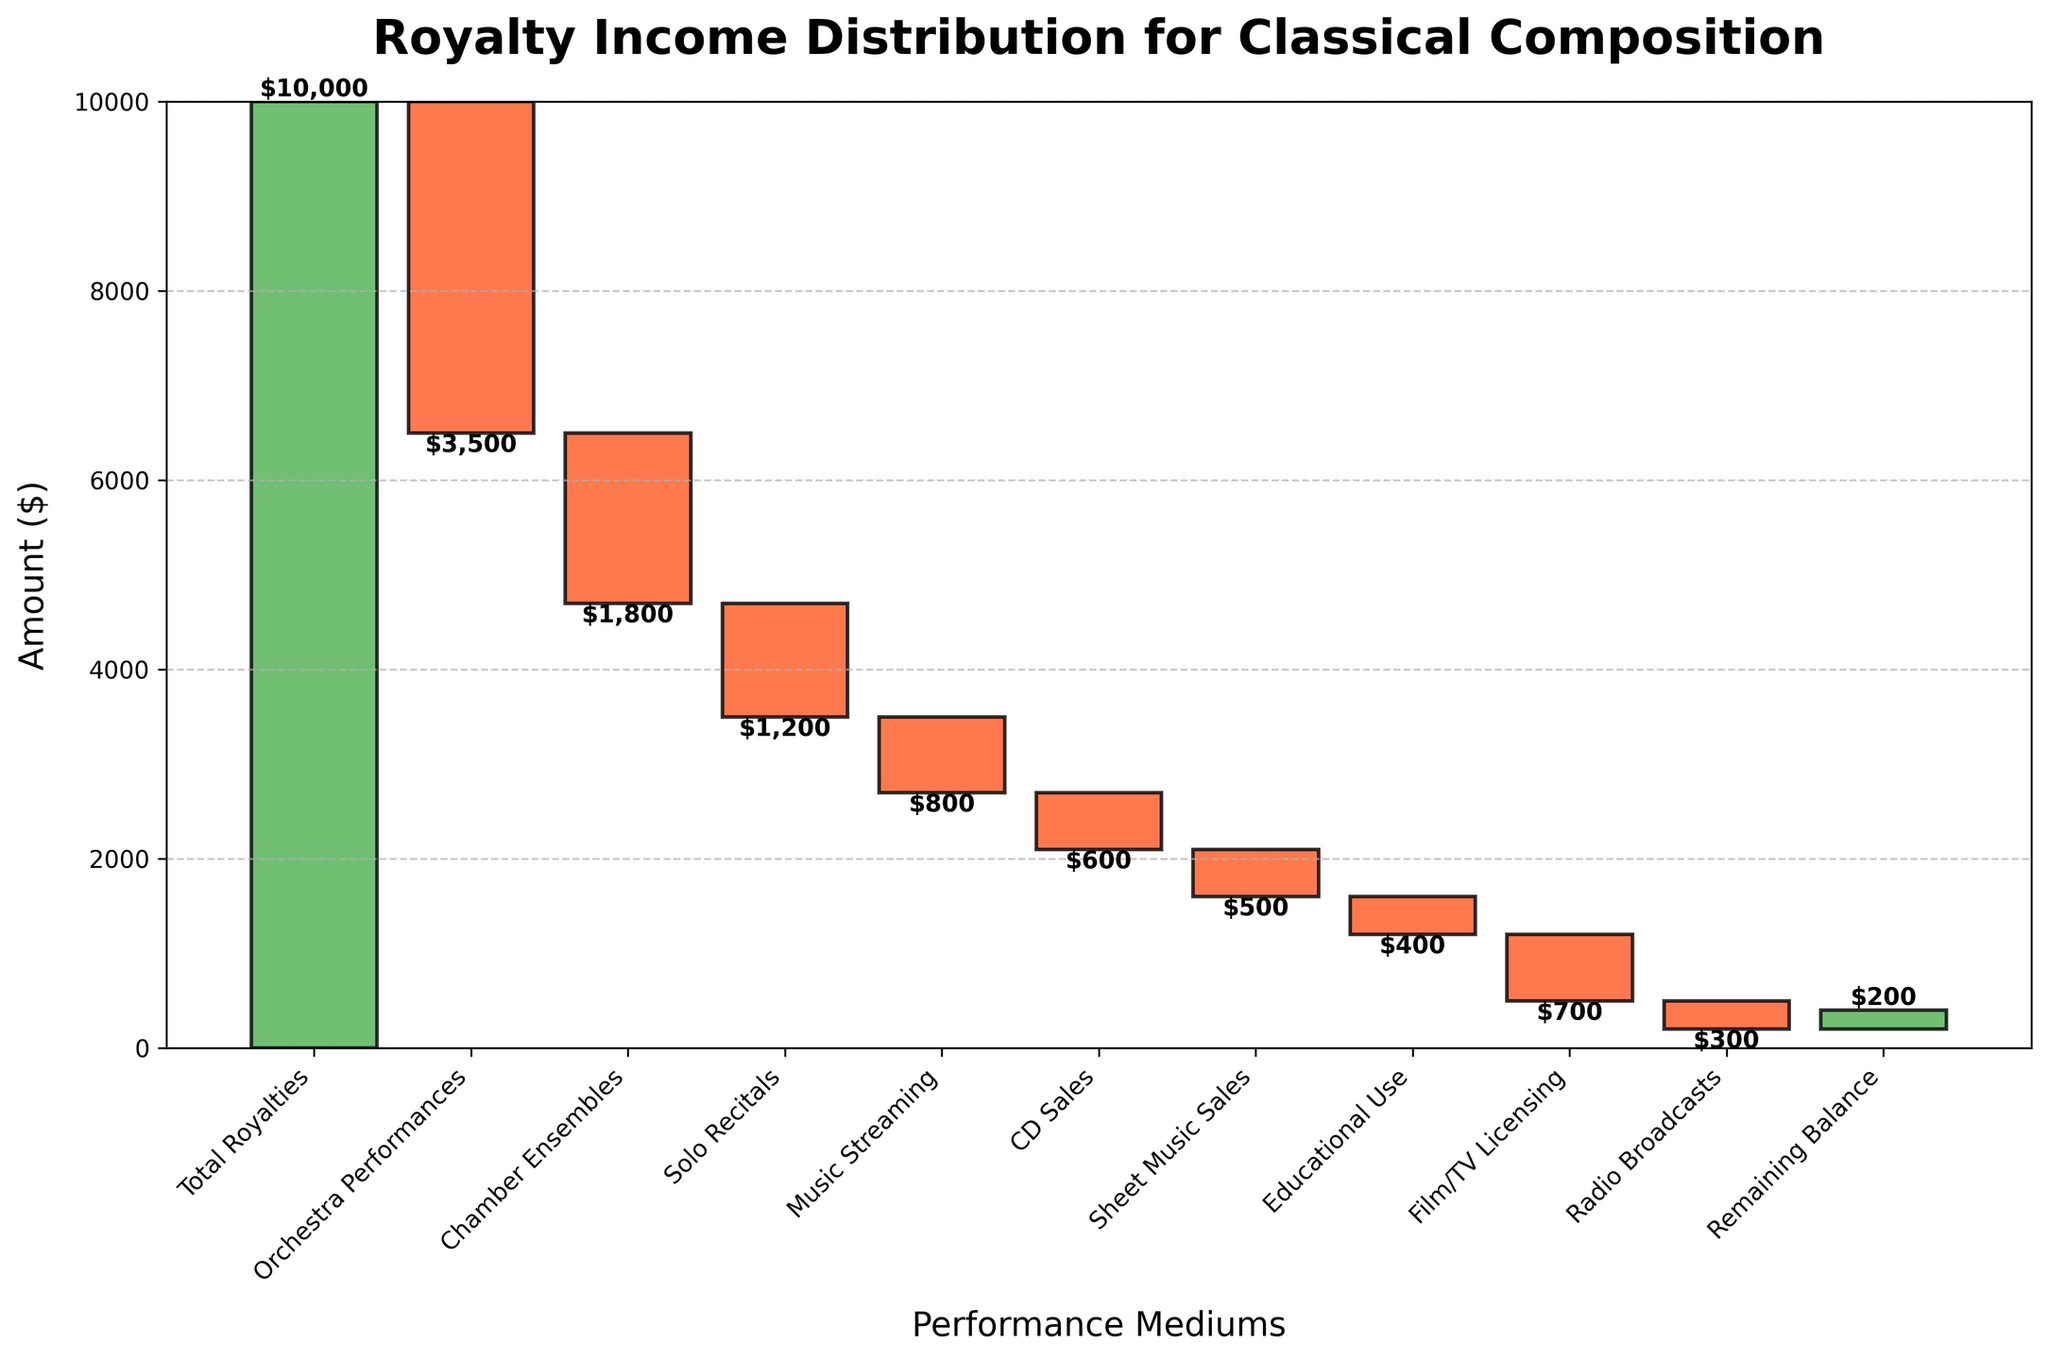how much is the total royalty income? The total royalty income is indicated by the "Total Royalties" category at the beginning of the chart. The value listed there is $10,000.
Answer: $10,000 Which category has the largest negative impact on the total royalties? To determine the largest negative impact, check the categories with red bars and find the one with the largest absolute value. "Orchestra Performances" has the largest negative amount of -$3,500.
Answer: Orchestra Performances What is the remaining balance after all deductions? The remaining balance is represented by the last category, "Remaining Balance," in the chart. The value listed there is $200.
Answer: $200 Which performance medium has the lowest royalties deducted? To find the lowest deducted amount, compare all the negative amounts and find the smallest absolute value. "Radio Broadcasts" has the lowest deduction of -$300.
Answer: Radio Broadcasts In which categories are the deductions between $500 and $1000? Look for categories with negative amounts within the range of $500 to $1000. The categories that match this range are "Music Streaming" (-$800), "CD Sales" (-$600), "Sheet Music Sales" (-$500), and "Film/TV Licensing" (-$700).
Answer: Music Streaming, CD Sales, Sheet Music Sales, Film/TV Licensing What is the cumulative value after the "Chamber Ensembles" deduction? Calculate the cumulative sum after deducting "Chamber Ensembles." Starting from the total royalties of $10,000, subtract "Orchestra Performances" (-$3,500) and then "Chamber Ensembles" (-$1,800). The result is $10,000 - $3,500 - $1,800 = $4,700.
Answer: $4,700 How much more are the royalties from "Educational Use" compared to "Radio Broadcasts"? Compare the negative amounts of "Educational Use" and "Radio Broadcasts." "Educational Use" has -$400, and "Radio Broadcasts" has -$300. So, the difference is $400 - $300 = $100.
Answer: $100 If orchestras double their royalty contribution next year, how would that affect the total royalties? If the deduction for "Orchestra Performances" is doubled, it would be 2 * $3,500 = $7,000. Subtract this new value from the total royalties: $10,000 - $7,000 = $3,000. This would decrease the remaining balance to $3,000.
Answer: $3,000 What is the average deduction across all performance mediums? To find the average deduction, sum up all negative amounts and divide by the number of categories with deductions. The total deductions are $3,500 + $1,800 + $1,200 + $800 + $600 + $500 + $400 + $700 + $300 = $9,800. There are 9 deductive categories, so the average is $9,800 / 9 ≈ $1,089.
Answer: $1,089 Which category's deduction is closest to the average deduction? From earlier, the average deduction is approximately $1,089. Compare the deductive categories to find the closest value. "Chamber Ensembles" have a deduction of -$1,800, which is closest to $1,089.
Answer: Chamber Ensembles 